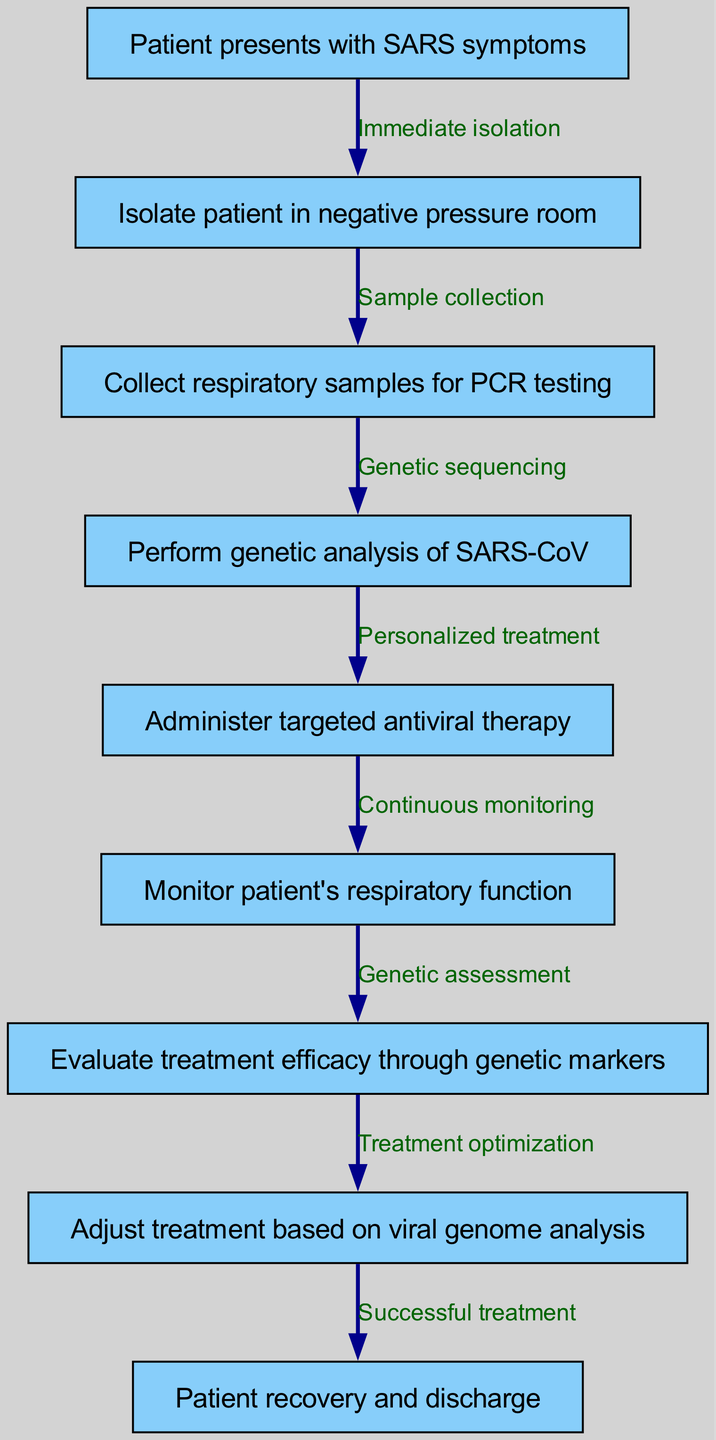What is the first step in the patient care pathway for SARS? The first step in the pathway is represented by the node labeled "Patient presents with SARS symptoms." This is the starting point of the clinical pathway, indicating what occurs before any actions are taken.
Answer: Patient presents with SARS symptoms How many nodes are present in the clinical pathway? To determine the total number of nodes, I can count the entries in the "nodes" list from the provided data. There are nine distinct nodes in the diagram, each representing a specific step or event in the clinical pathway for SARS.
Answer: 9 What type of room should the patient be isolated in after presenting symptoms? The diagram specifically states that upon presenting symptoms, the patient should be "Isolate patient in negative pressure room." This step is crucial for preventing the spread of the airborne pathogen during initial treatment.
Answer: Negative pressure room What is the relationship between collecting respiratory samples and genetic analysis? The relationship indicated in the diagram shows a sequence where "Collect respiratory samples for PCR testing" directly leads to "Perform genetic analysis of SARS-CoV." This implies that the samples collected are essential for the subsequent genetic analysis.
Answer: Genetic sequencing What action is taken after administering antiviral therapy? Following the step "Administer targeted antiviral therapy," the subsequent action in the clinical pathway is "Monitor patient's respiratory function." This indicates the need for ongoing observation after treatment initiation.
Answer: Monitor patient's respiratory function What is assessed to evaluate the treatment efficacy? The diagram outlines that "Evaluate treatment efficacy through genetic markers" follows the step of monitoring the patient's condition. This suggests that genetic markers are crucial indicators for assessing how well the treatment is working.
Answer: Genetic markers How will treatment adjustments be made based on the pathway? The pathway shows that after evaluating treatment efficacy, the next action is "Adjust treatment based on viral genome analysis." This indicates that the adjustments to treatment will be informed by the analysis of the viral genome.
Answer: Viral genome analysis What leads to patient recovery and discharge? The flow of the diagram indicates that the step "Adjust treatment based on viral genome analysis" directly leads to "Patient recovery and discharge." This suggests that once the treatment is appropriately adjusted, it results in the patient's recovery and preparation for discharge.
Answer: Successful treatment 